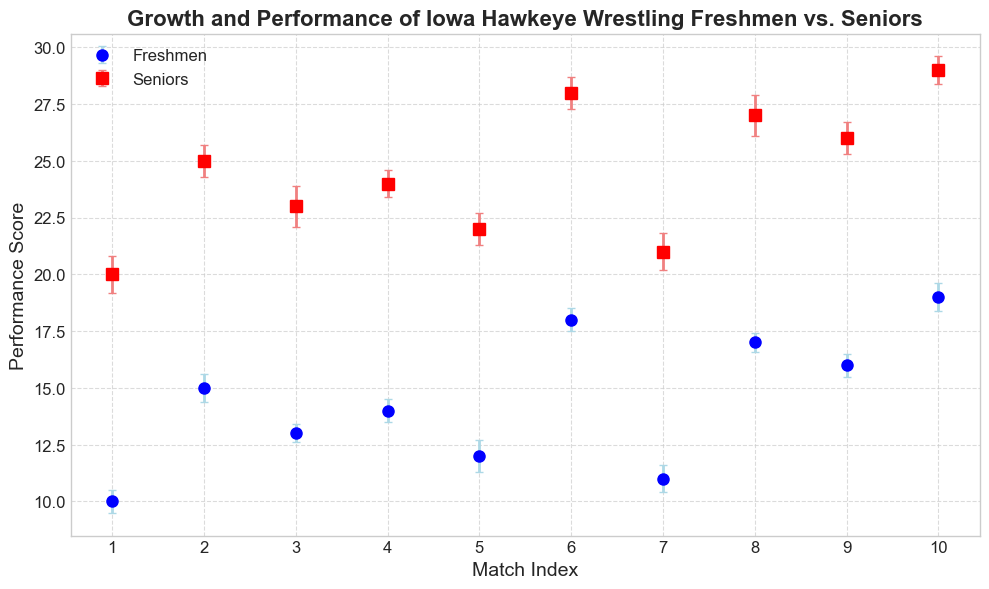What is the difference between the highest performance scores of freshmen and seniors? The highest performance score for freshmen is 19 and for seniors, it is 29. The difference is 29 - 19
Answer: 10 Which group has a broader range of performance scores, freshmen or seniors? The range of performance scores for freshmen is from 10 to 19, a span of 9. For seniors, it’s from 20 to 29, a span of 9 as well. Hence, both groups have the same range.
Answer: Both Looking at match index 4, which group has a higher performance score and by how much? For match index 4, freshmen have a performance score of 14, while seniors have a score of 24. The difference is 24 - 14 = 10
Answer: Seniors by 10 What can you infer about the error margins for the performance scores of freshmen and seniors? The error margins for freshmen vary between 0.4 and 0.7, while for seniors, they range from 0.6 to 0.9. Seniors generally have larger error margins than freshmen.
Answer: Seniors have larger error margins On average, which group has higher performance scores? The average performance score for freshmen is (10 + 15 + 13 + 14 + 12 + 18 + 11 + 17 + 16 + 19) / 10 = 145 / 10 = 14.5. For seniors, it's (20 + 25 + 23 + 24 + 22 + 28 + 21 + 27 + 26 + 29) / 10 = 245 / 10 = 24.5. Seniors have higher average performance scores.
Answer: Seniors Considering the error bars, which group shows more consistency in performance? Freshmen have smaller error margins (0.4 to 0.7) compared to seniors (0.6 to 0.9), indicating that freshmen show more consistency in their performance scores.
Answer: Freshmen If we compare match index 7, what can you say about the error margins of freshmen and seniors? At match index 7, the error margin for freshmen is 0.6, while for seniors, it is 0.8. The error margin for seniors is thus greater by 0.2 than that of freshmen.
Answer: Seniors have a larger error margin of 0.2 more Which match index has the smallest performance difference between freshmen and seniors? At match index 1, the difference between freshmen (10) and seniors (20) is 10. At match index 2, it's 10 as well. Index 3 has 10, index 4 has 10, index 5 has 10, index 6 has 10, index 7 has 10, index 8 has 10, index 9 has 10, and index 10 has 10. All match indices have the same difference of 10.
Answer: All indices with a difference of 10 What visual attributes distinguish the freshmen and seniors' performance scores? Freshmen's performance scores are represented by blue circles with light blue error bars, whereas seniors' scores are depicted by red squares with light coral error bars.
Answer: Freshmen: blue circles, Seniors: red squares 